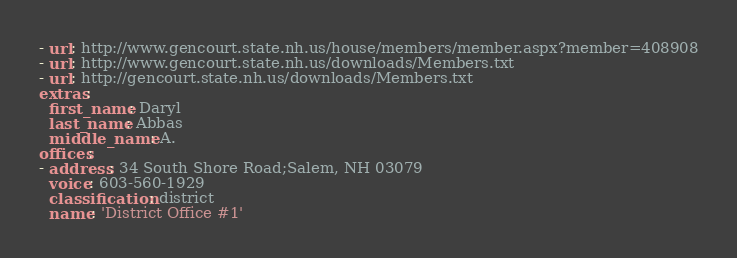Convert code to text. <code><loc_0><loc_0><loc_500><loc_500><_YAML_>- url: http://www.gencourt.state.nh.us/house/members/member.aspx?member=408908
- url: http://www.gencourt.state.nh.us/downloads/Members.txt
- url: http://gencourt.state.nh.us/downloads/Members.txt
extras:
  first_name: Daryl
  last_name: Abbas
  middle_name: A.
offices:
- address: 34 South Shore Road;Salem, NH 03079
  voice: 603-560-1929
  classification: district
  name: 'District Office #1'
</code> 